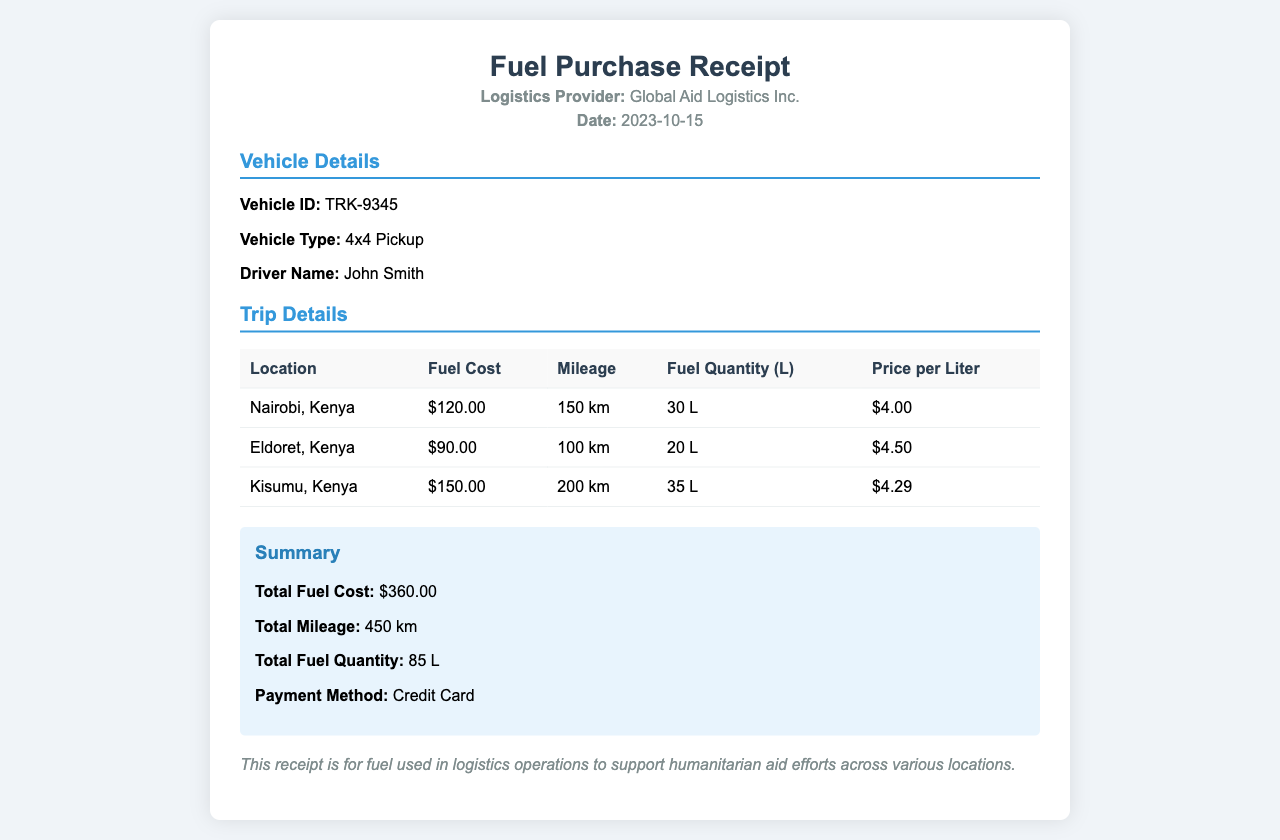What is the total fuel cost? The total fuel cost is provided in the summary section of the receipt, which states that it is $360.00.
Answer: $360.00 What is the total mileage incurred? Total mileage is listed in the summary section of the receipt, which indicates a total of 450 km.
Answer: 450 km What is the date of the receipt? The date is mentioned in the header section of the receipt, which shows it as 2023-10-15.
Answer: 2023-10-15 Who is the driver of the vehicle? The driver's name is specified in the vehicle details section, which identifies the driver as John Smith.
Answer: John Smith What is the vehicle ID? The vehicle ID can be found under the vehicle details section, listed as TRK-9345.
Answer: TRK-9345 Which location incurred the highest fuel cost? By comparing the fuel costs listed for each location, Kisumu, Kenya has the highest fuel cost at $150.00.
Answer: Kisumu, Kenya How much fuel was purchased in Eldoret? The fuel quantity purchased in Eldoret is noted in the trip details table as 20 L.
Answer: 20 L What is the price per liter in Nairobi? The price per liter for fuel in Nairobi is listed in the trip details as $4.00.
Answer: $4.00 What method of payment was used for this purchase? The payment method is mentioned in the summary section, specifying that it was made by credit card.
Answer: Credit Card 